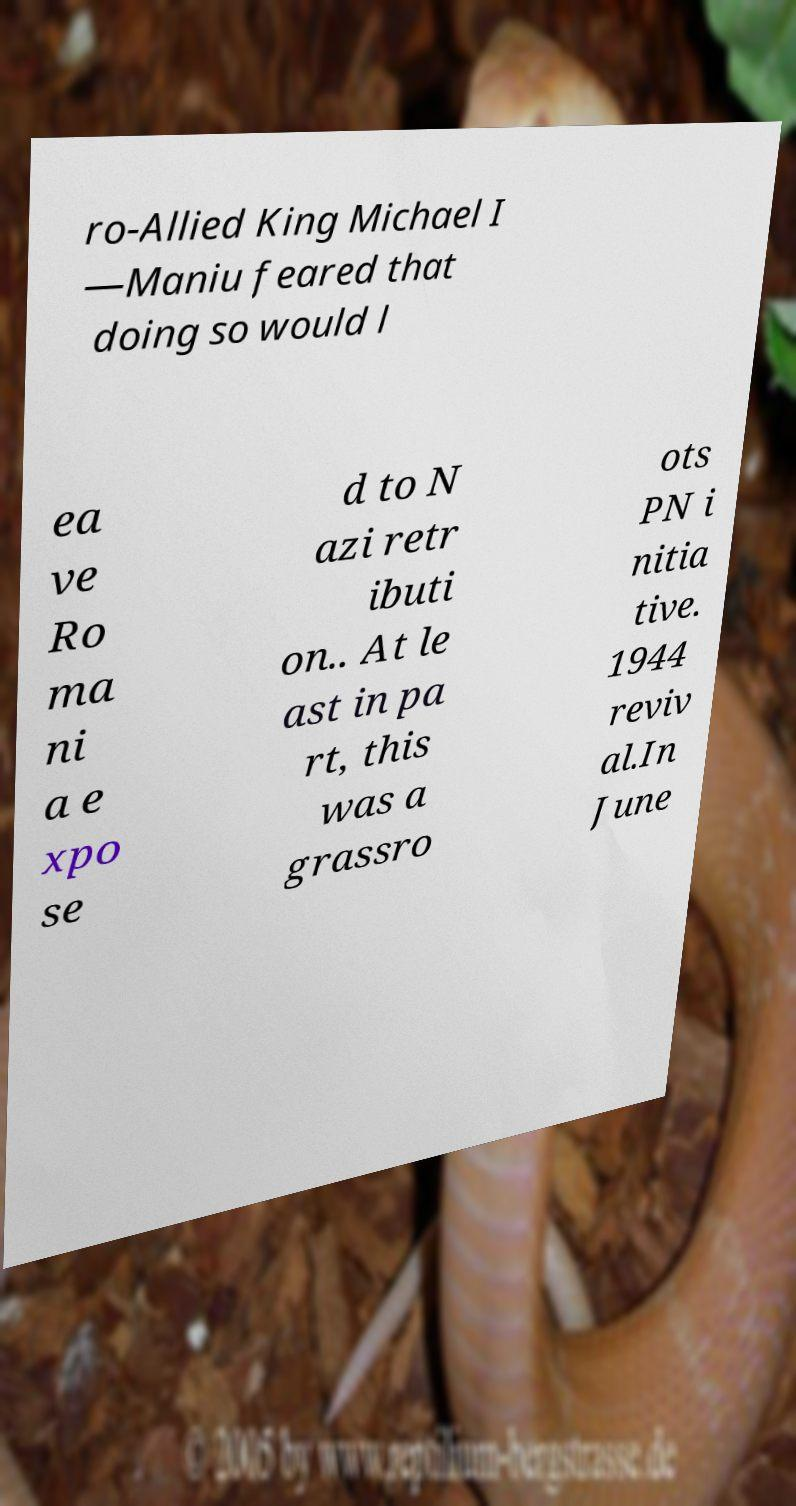Could you extract and type out the text from this image? ro-Allied King Michael I —Maniu feared that doing so would l ea ve Ro ma ni a e xpo se d to N azi retr ibuti on.. At le ast in pa rt, this was a grassro ots PN i nitia tive. 1944 reviv al.In June 